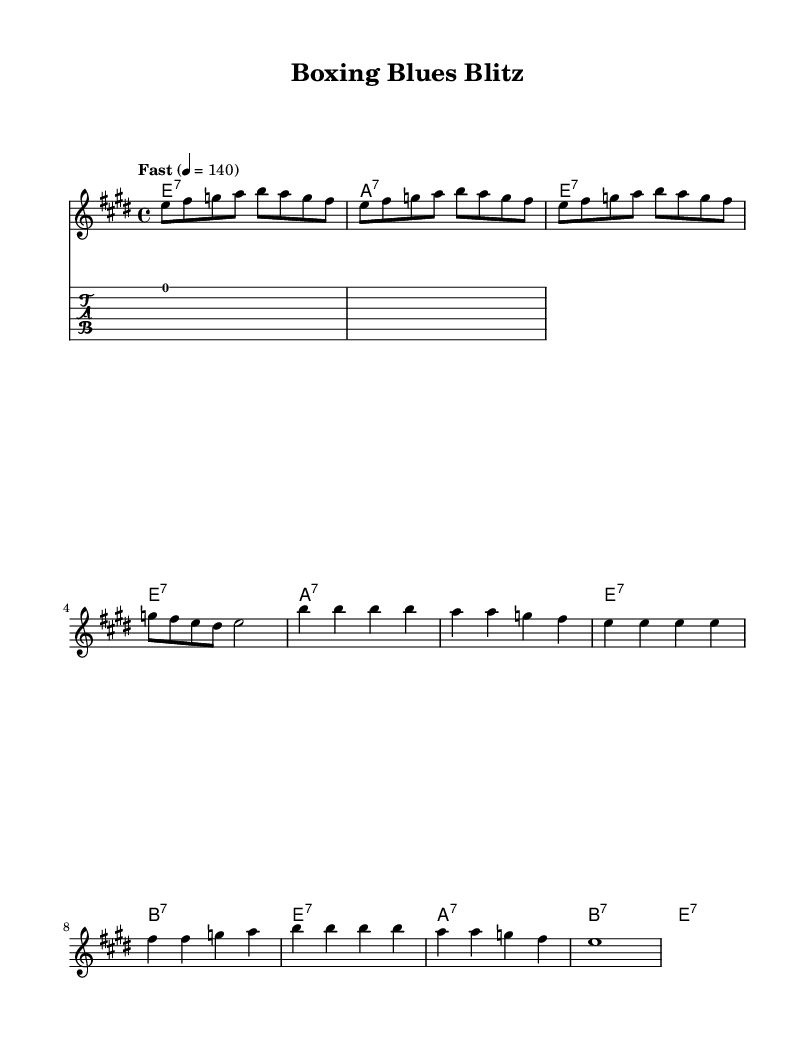What is the key signature of this music? The key signature is E major, which has four sharps (F#, C#, G#, D#). This is evident from the key signature marking at the beginning of the score.
Answer: E major What is the time signature of this music? The time signature is 4/4, which means there are four beats in a measure and a quarter note receives one beat. This can be seen next to the clef at the start of the score.
Answer: 4/4 What is the tempo marking of this music? The tempo marking indicates "Fast" at a speed of 140 beats per minute, which suggests a high-energy pace suitable for electric blues. This is specified under the tempo directive at the beginning of the score.
Answer: Fast, 140 How many measures are in the verse section? The verse section consists of 8 measures, as counted from the melody line which has 4 measures while the harmonies provide support throughout the phrase structure.
Answer: 8 Which chord appears most frequently in the harmonies? The E major 7 chord appears most frequently throughout the verse section, as it is used in multiple measures compared to the other chords. This can be determined by analyzing the chord sequence provided in the score.
Answer: E1:7 What is the rhythmic structure of the chorus? The chorus features a repetitive rhythmic structure that typically uses quarter notes on the strong beats and longer notes that add to the overall driving feel of electric blues. Observing the rhythmic values in the chorus bars shows this pattern clearly.
Answer: Repetitive quarter notes Which section contains the highest note? The highest note in the piece occurs in the chorus, specifically at the "b'4" note, which is an octave above the other notes in the melody and signifies a peak moment in the song's energy. This can be identified by examining the melody line in the chorus section.
Answer: b' 